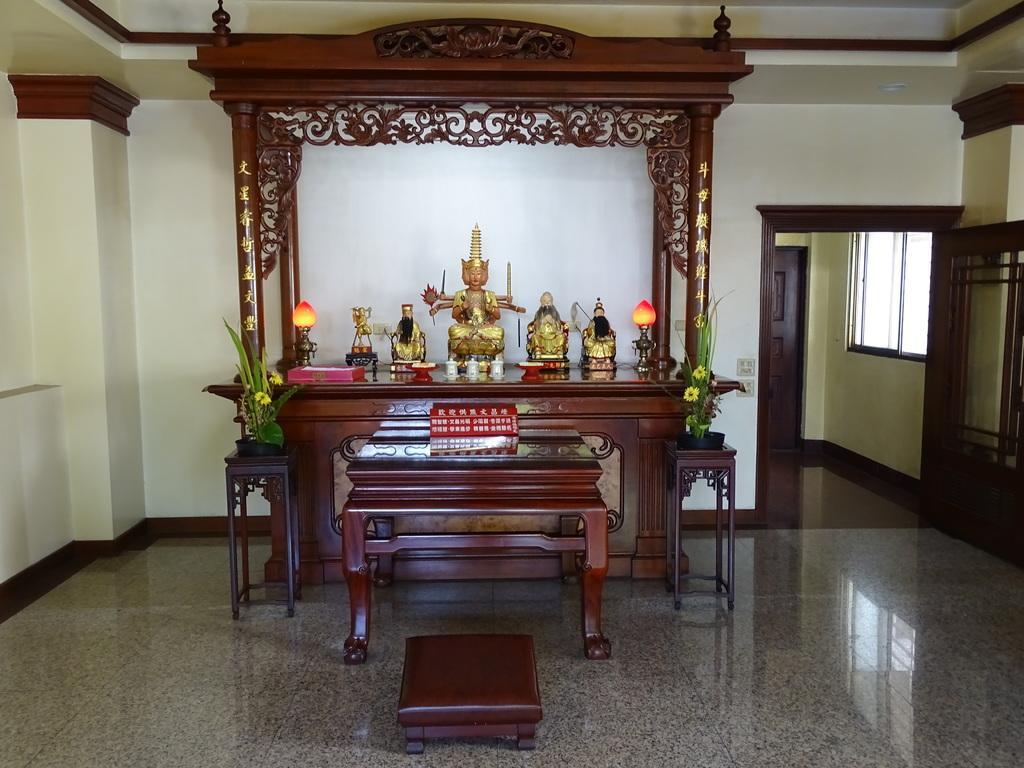In one or two sentences, can you explain what this image depicts? In this image we can see the inner view of a room. In the room we can see house plants, side table, statues in the cupboard, walls and doors. 